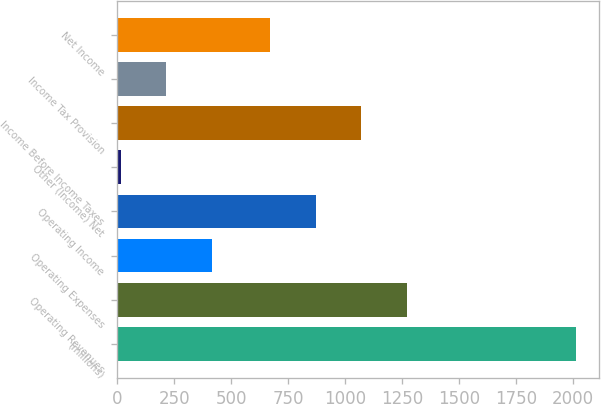Convert chart. <chart><loc_0><loc_0><loc_500><loc_500><bar_chart><fcel>(millions)<fcel>Operating Revenues<fcel>Operating Expenses<fcel>Operating Income<fcel>Other (Income) Net<fcel>Income Before Income Taxes<fcel>Income Tax Provision<fcel>Net Income<nl><fcel>2013<fcel>1269.7<fcel>413.8<fcel>869.9<fcel>14<fcel>1069.8<fcel>213.9<fcel>670<nl></chart> 